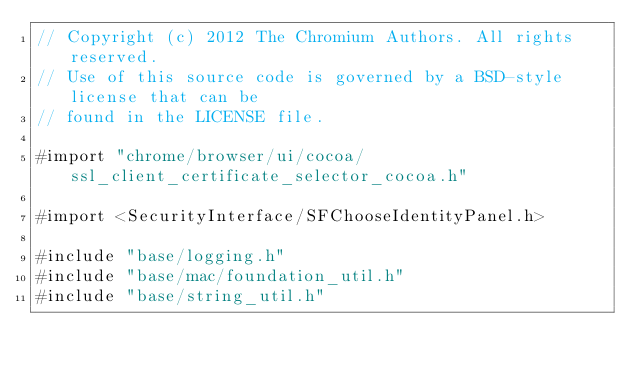Convert code to text. <code><loc_0><loc_0><loc_500><loc_500><_ObjectiveC_>// Copyright (c) 2012 The Chromium Authors. All rights reserved.
// Use of this source code is governed by a BSD-style license that can be
// found in the LICENSE file.

#import "chrome/browser/ui/cocoa/ssl_client_certificate_selector_cocoa.h"

#import <SecurityInterface/SFChooseIdentityPanel.h>

#include "base/logging.h"
#include "base/mac/foundation_util.h"
#include "base/string_util.h"</code> 